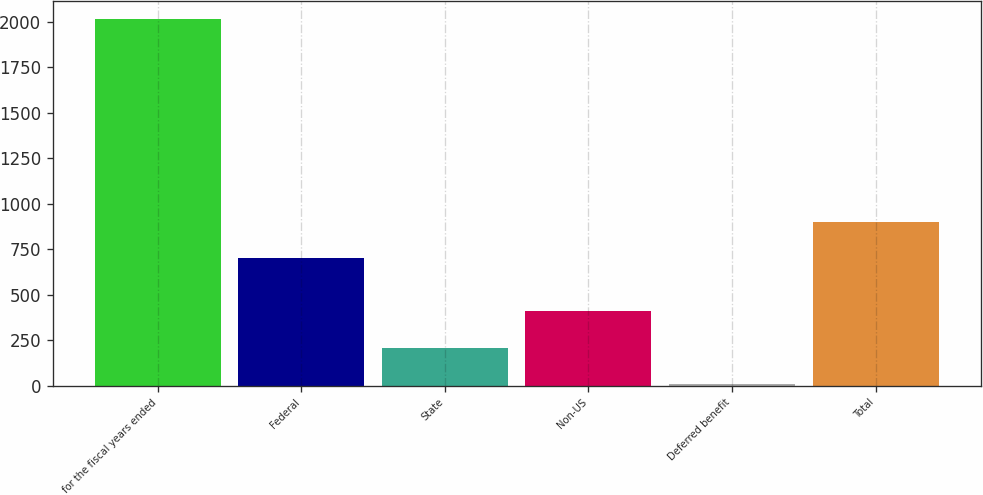<chart> <loc_0><loc_0><loc_500><loc_500><bar_chart><fcel>for the fiscal years ended<fcel>Federal<fcel>State<fcel>Non-US<fcel>Deferred benefit<fcel>Total<nl><fcel>2013<fcel>699.6<fcel>206.88<fcel>407.56<fcel>6.2<fcel>900.28<nl></chart> 